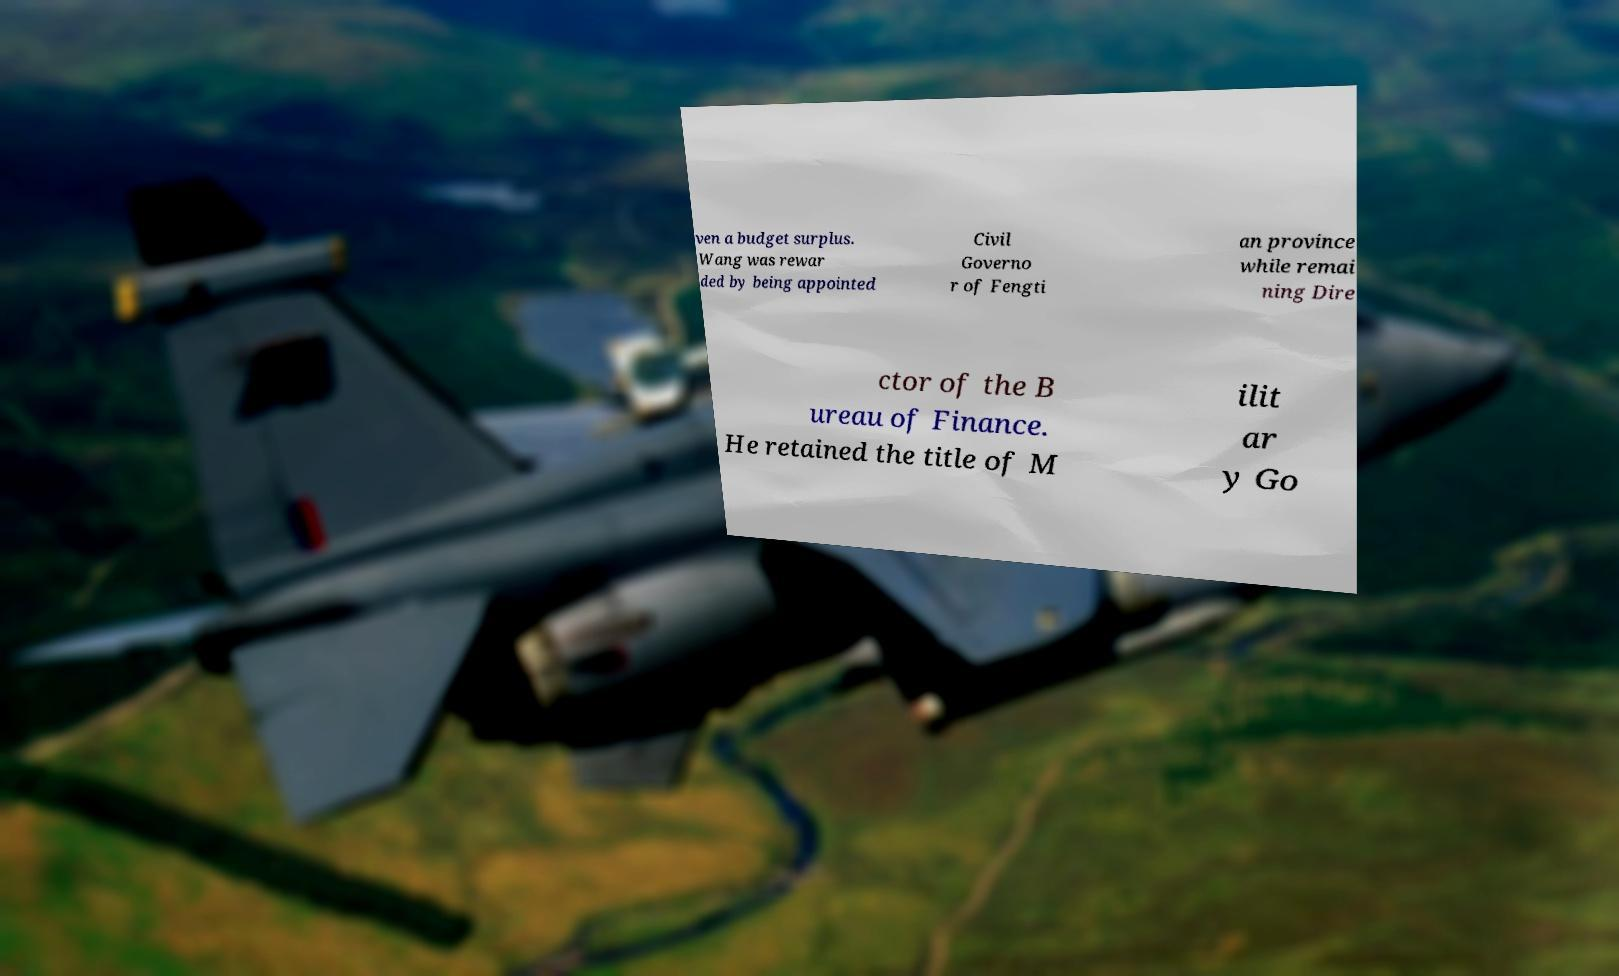What messages or text are displayed in this image? I need them in a readable, typed format. ven a budget surplus. Wang was rewar ded by being appointed Civil Governo r of Fengti an province while remai ning Dire ctor of the B ureau of Finance. He retained the title of M ilit ar y Go 